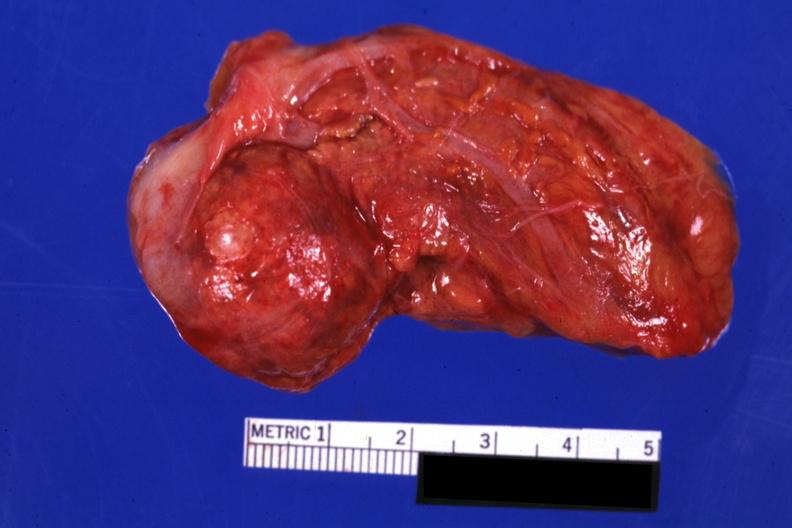what does this image show?
Answer the question using a single word or phrase. Intact gland with obvious nodule 